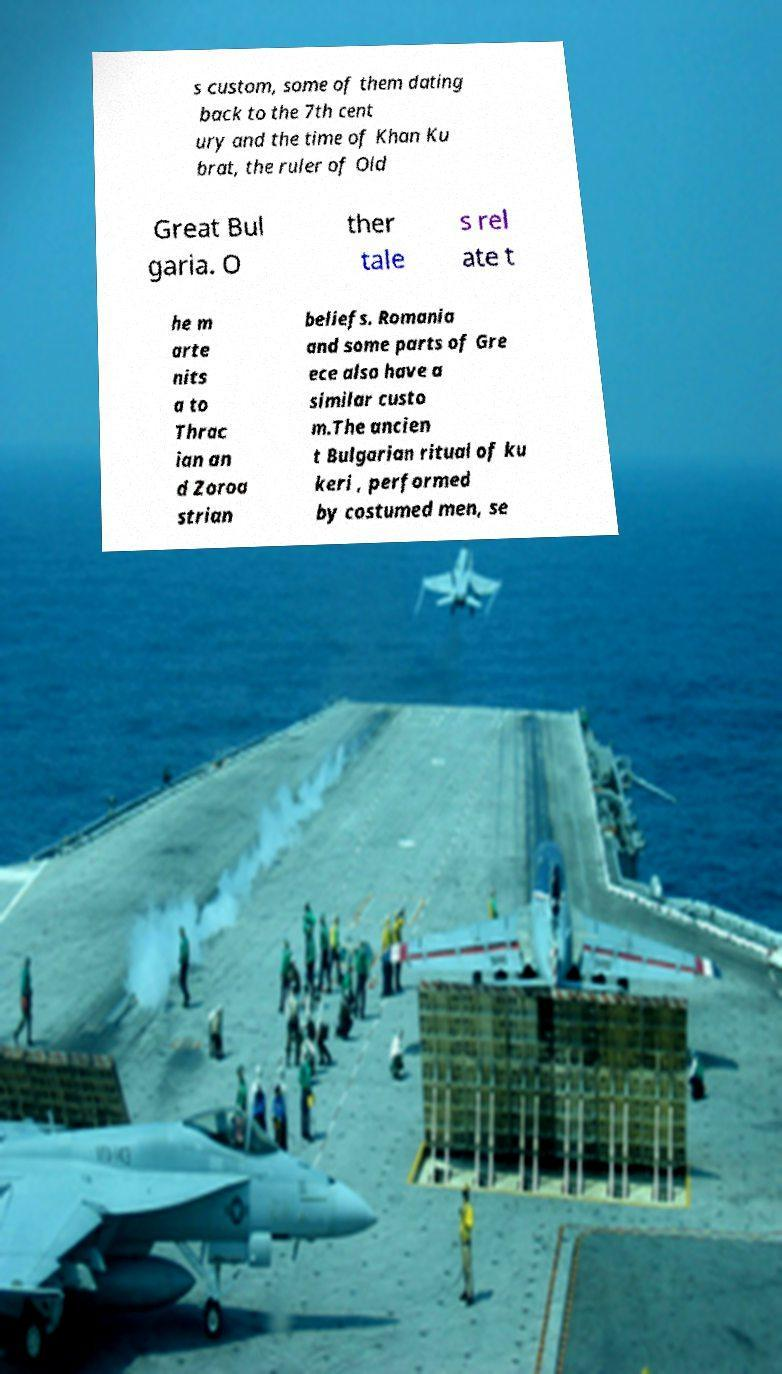I need the written content from this picture converted into text. Can you do that? s custom, some of them dating back to the 7th cent ury and the time of Khan Ku brat, the ruler of Old Great Bul garia. O ther tale s rel ate t he m arte nits a to Thrac ian an d Zoroa strian beliefs. Romania and some parts of Gre ece also have a similar custo m.The ancien t Bulgarian ritual of ku keri , performed by costumed men, se 